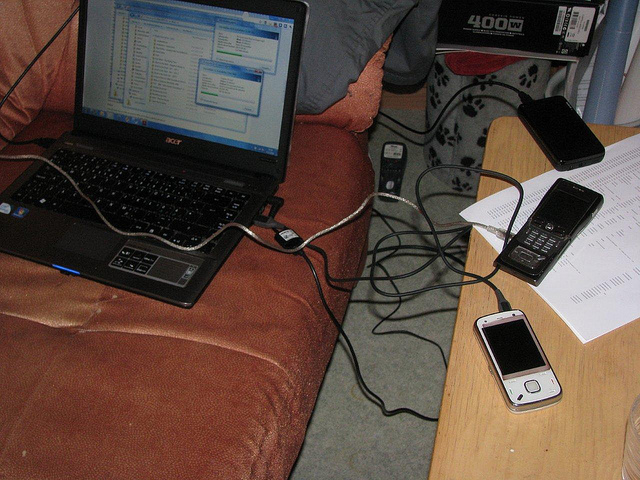Please transcribe the text in this image. 4000 w 